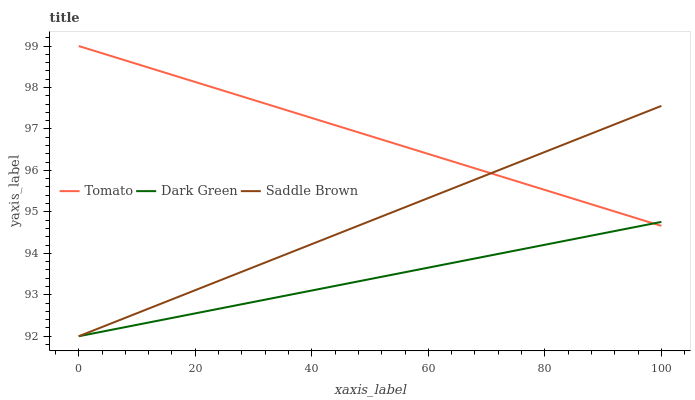Does Saddle Brown have the minimum area under the curve?
Answer yes or no. No. Does Saddle Brown have the maximum area under the curve?
Answer yes or no. No. Is Saddle Brown the smoothest?
Answer yes or no. No. Is Dark Green the roughest?
Answer yes or no. No. Does Saddle Brown have the highest value?
Answer yes or no. No. 